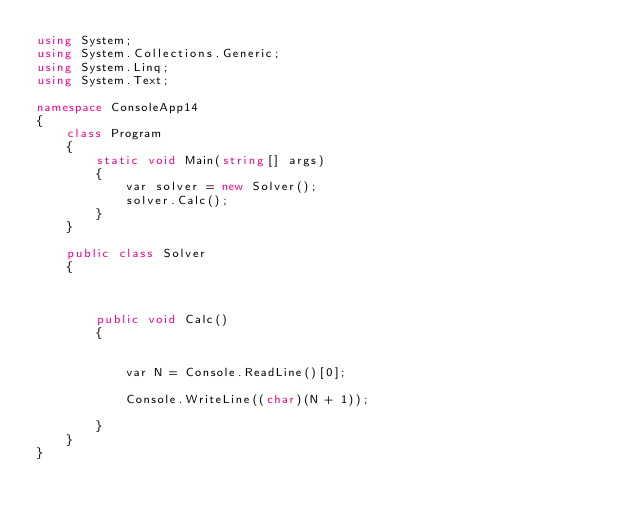<code> <loc_0><loc_0><loc_500><loc_500><_C#_>using System;
using System.Collections.Generic;
using System.Linq;
using System.Text;

namespace ConsoleApp14
{
    class Program
    {
        static void Main(string[] args)
        {
            var solver = new Solver();
            solver.Calc();
        }
    }

    public class Solver
    {



        public void Calc()
        {


            var N = Console.ReadLine()[0];

            Console.WriteLine((char)(N + 1));

        }
    }
}</code> 